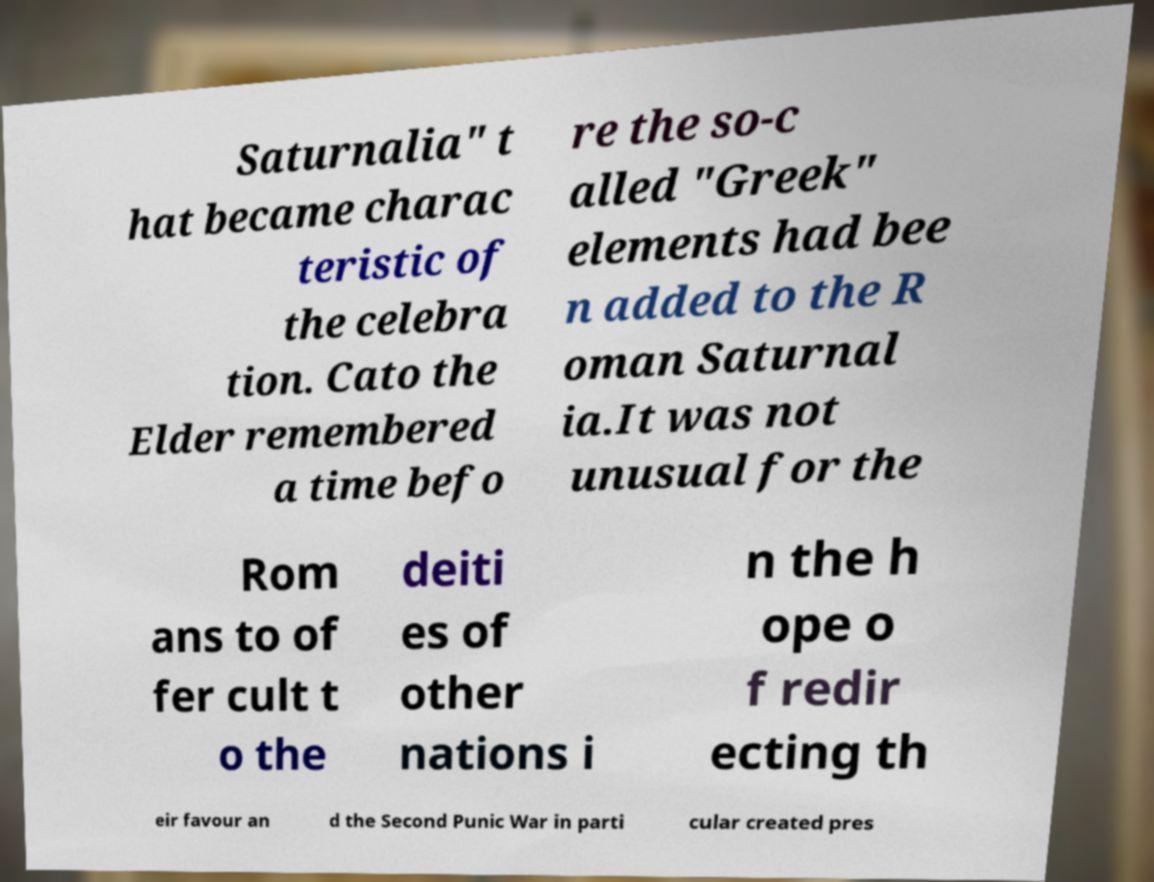There's text embedded in this image that I need extracted. Can you transcribe it verbatim? Saturnalia" t hat became charac teristic of the celebra tion. Cato the Elder remembered a time befo re the so-c alled "Greek" elements had bee n added to the R oman Saturnal ia.It was not unusual for the Rom ans to of fer cult t o the deiti es of other nations i n the h ope o f redir ecting th eir favour an d the Second Punic War in parti cular created pres 